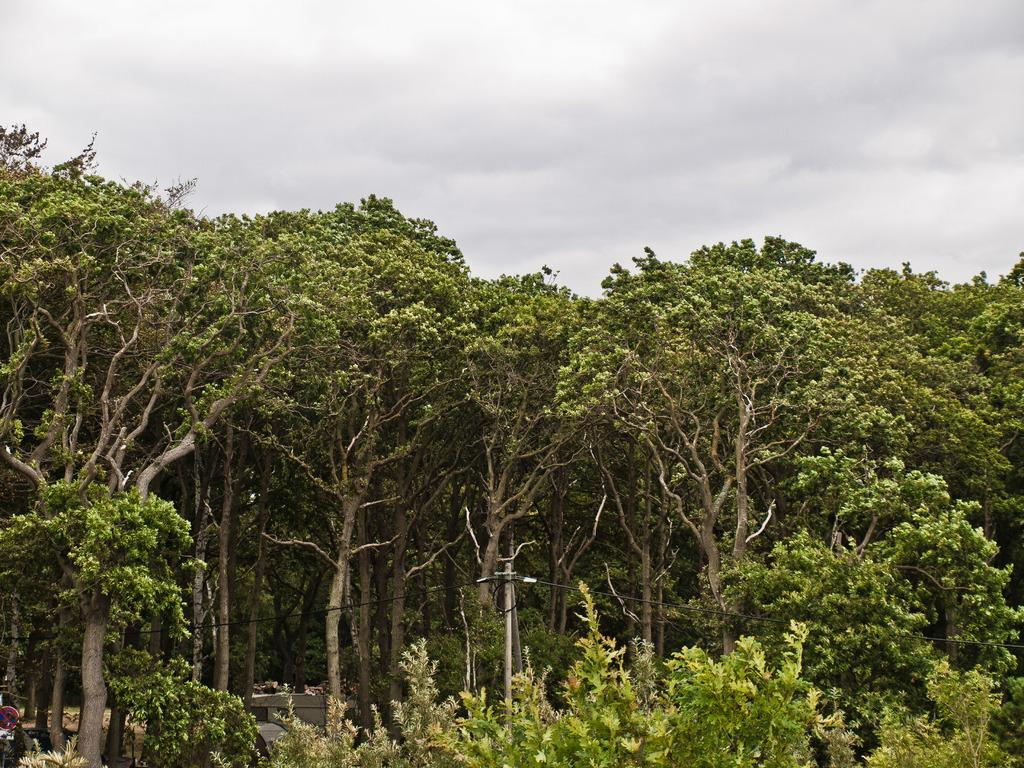What type of vegetation is on the front side of the image? There are plants on the front side of the image. What is attached to the pole in the image? There are wires attached to the pole in the image. What can be seen in the background of the image? There are trees and the sky visible in the background of the image. What is the condition of the sky in the image? The sky is visible in the background of the image, and clouds are present. What type of lace can be seen draped over the trees in the image? There is no lace present in the image; it features plants, a pole with wires, trees, and the sky with clouds. What experience can be gained from observing the representative in the image? There is no representative present in the image, so no experience can be gained from observing them. 